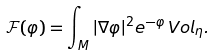Convert formula to latex. <formula><loc_0><loc_0><loc_500><loc_500>\mathcal { F } ( \varphi ) = \int _ { M } | \nabla \varphi | ^ { 2 } e ^ { - \varphi } \, V o l _ { \eta } .</formula> 